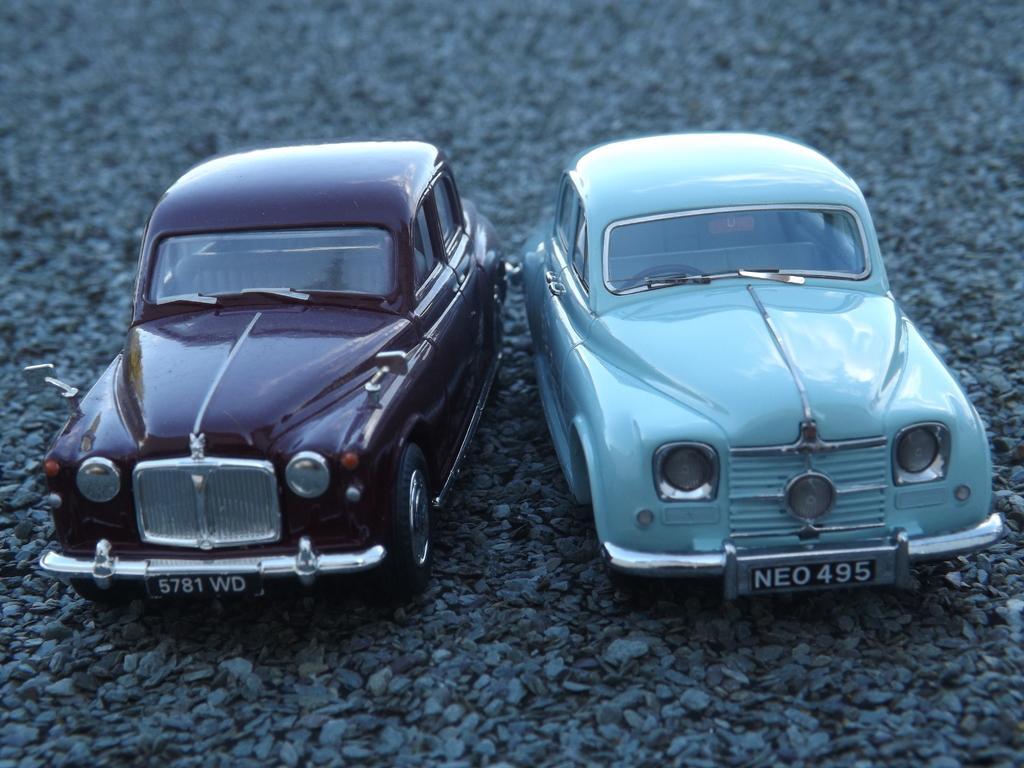In one or two sentences, can you explain what this image depicts? In the image there are two cars on the land with stone gravels on it. 